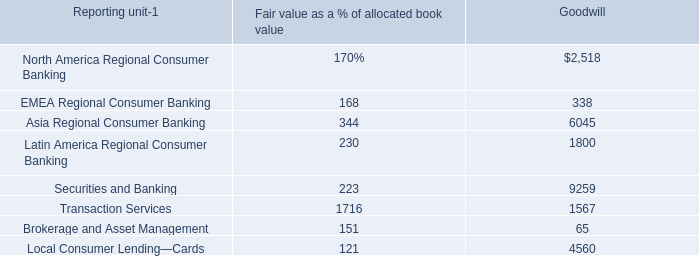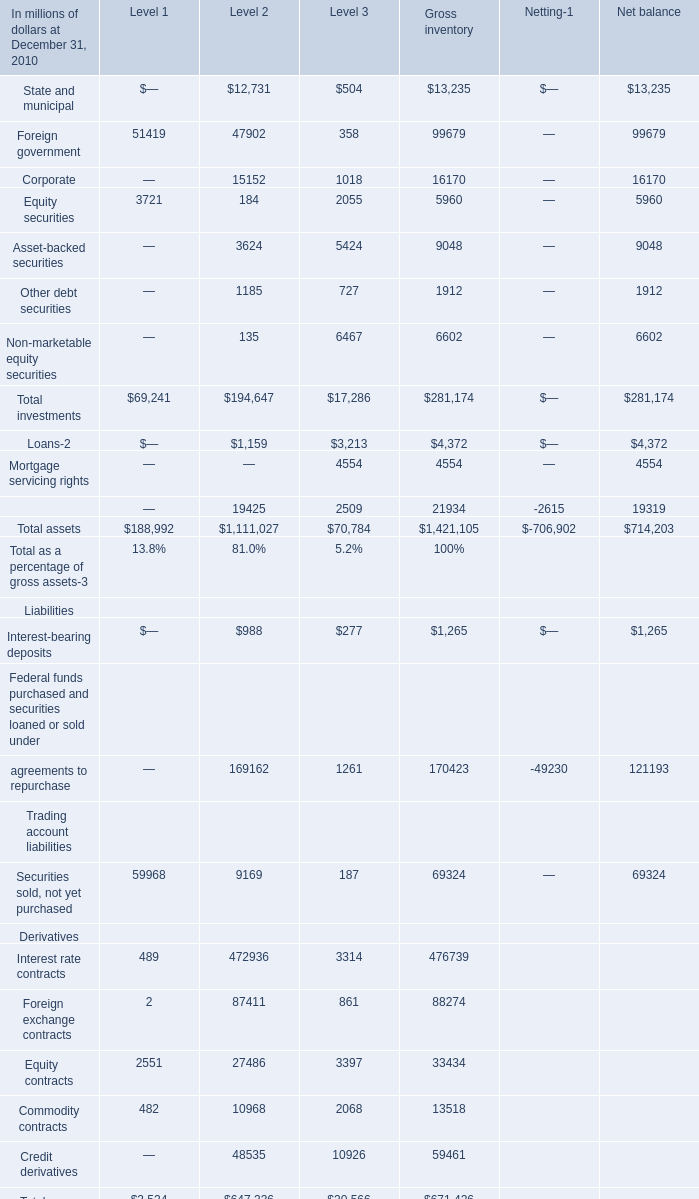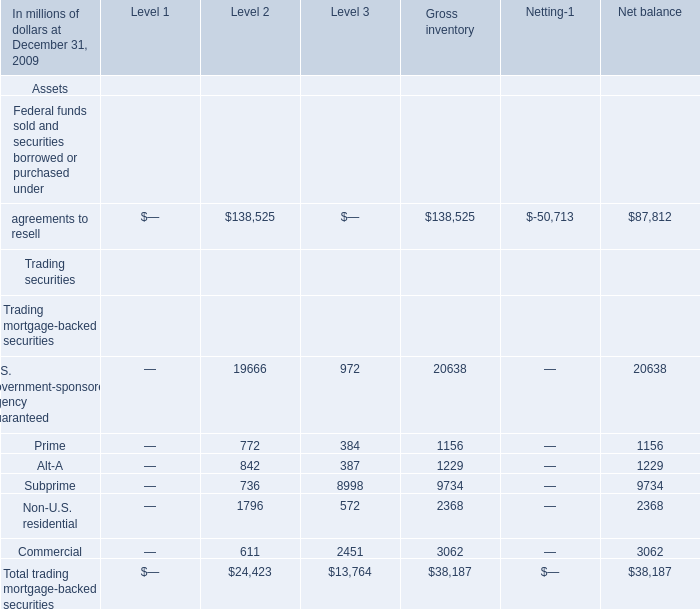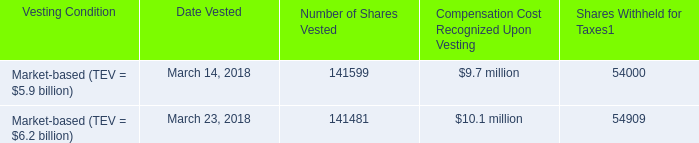In the section with largest amount of Foreign government, what's the sum of Equity securities and Total investments ? (in million) 
Computations: (3721 + 69241)
Answer: 72962.0. 